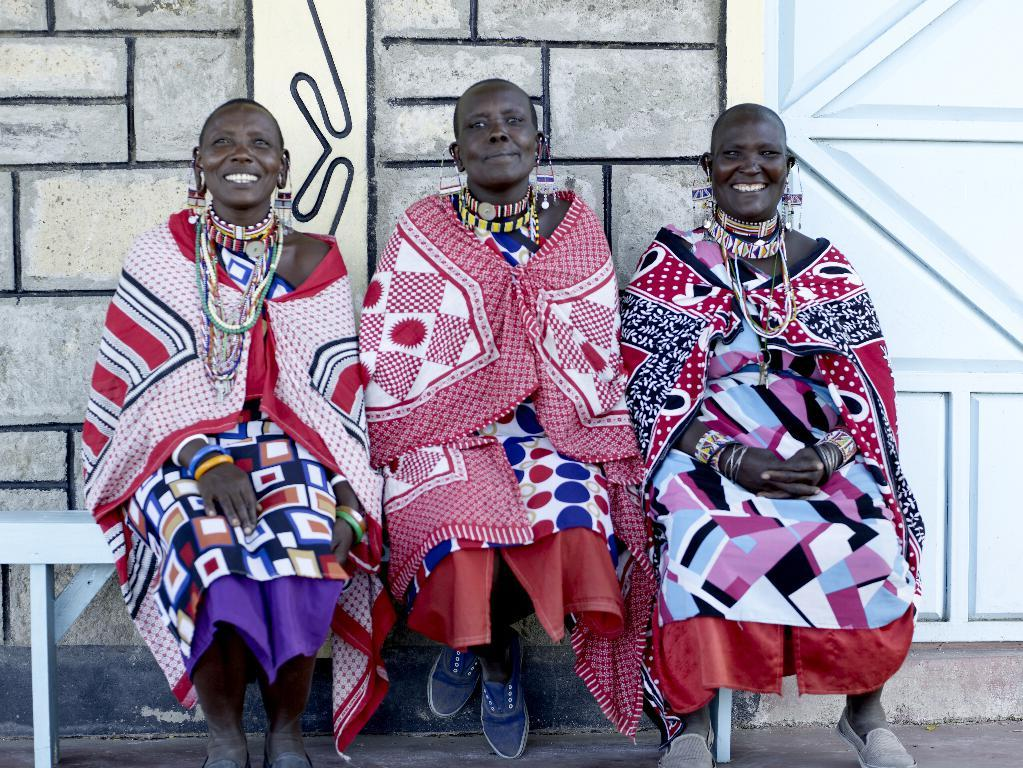How many people are in the image? There are three persons in the image. What are the persons doing in the image? The persons are sitting on a white bench. What can be seen behind the persons? There is a wall visible behind the persons. What is on the right side of the image? There is a white door on the right side of the image. What type of loss is being experienced by the persons in the image? There is no indication of any loss being experienced by the persons in the image. What type of office setting can be seen in the image? There is no office setting present in the image. 